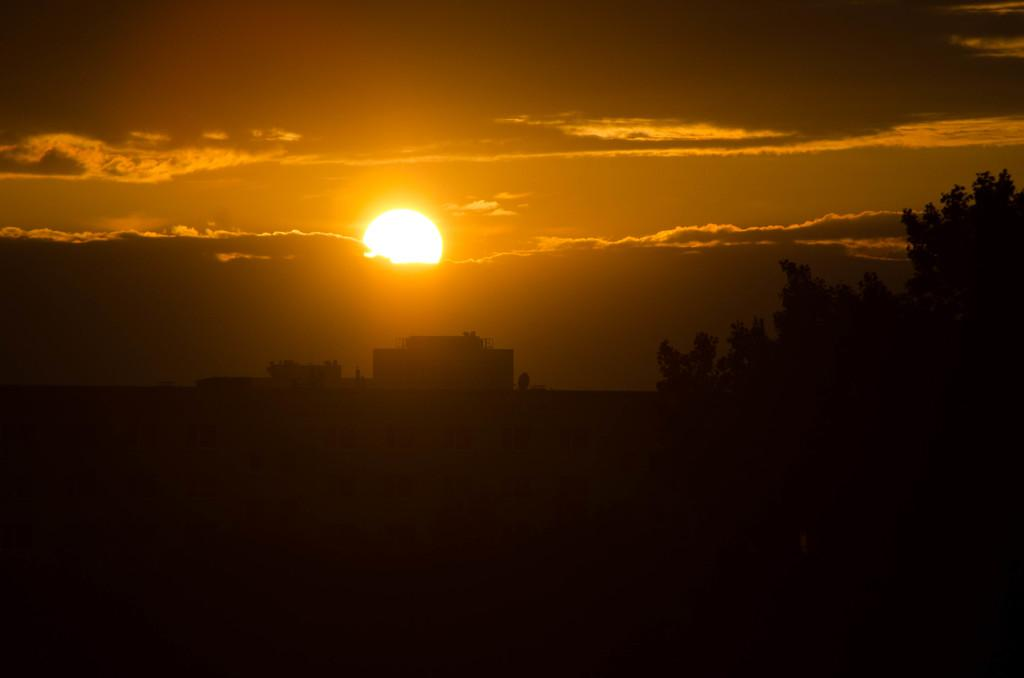What structures are located in the middle of the image? There are buildings in the middle of the image. What type of vegetation is on the right side of the image? There are trees on the right side of the image. What is the color of the bottom part of the image? The bottom part of the image is black in color. What is visible at the top of the image? The sky is visible at the top of the image. What can be seen in the sky? Clouds and the sun are present in the sky. Can you tell me how many matches are arranged in harmony in the image? There are no matches or any reference to harmony present in the image. Is there a rose visible in the image? There is no rose present in the image. 